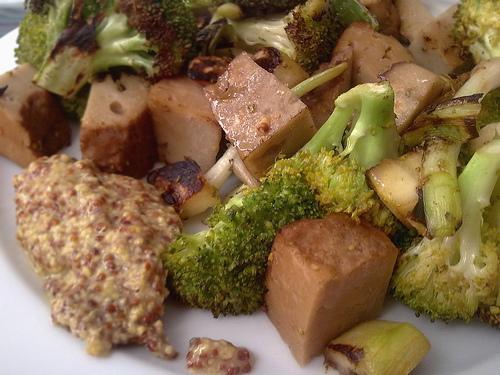How many plates are photographed?
Give a very brief answer. 1. 